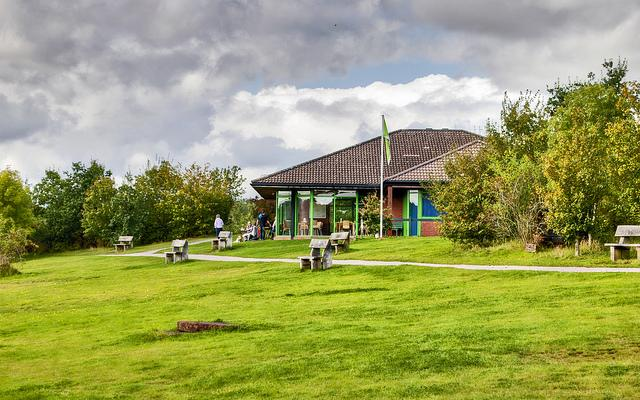What flowers might grow wild in this environment? Please explain your reasoning. dandelions. They are found in a lot of grassy areas 